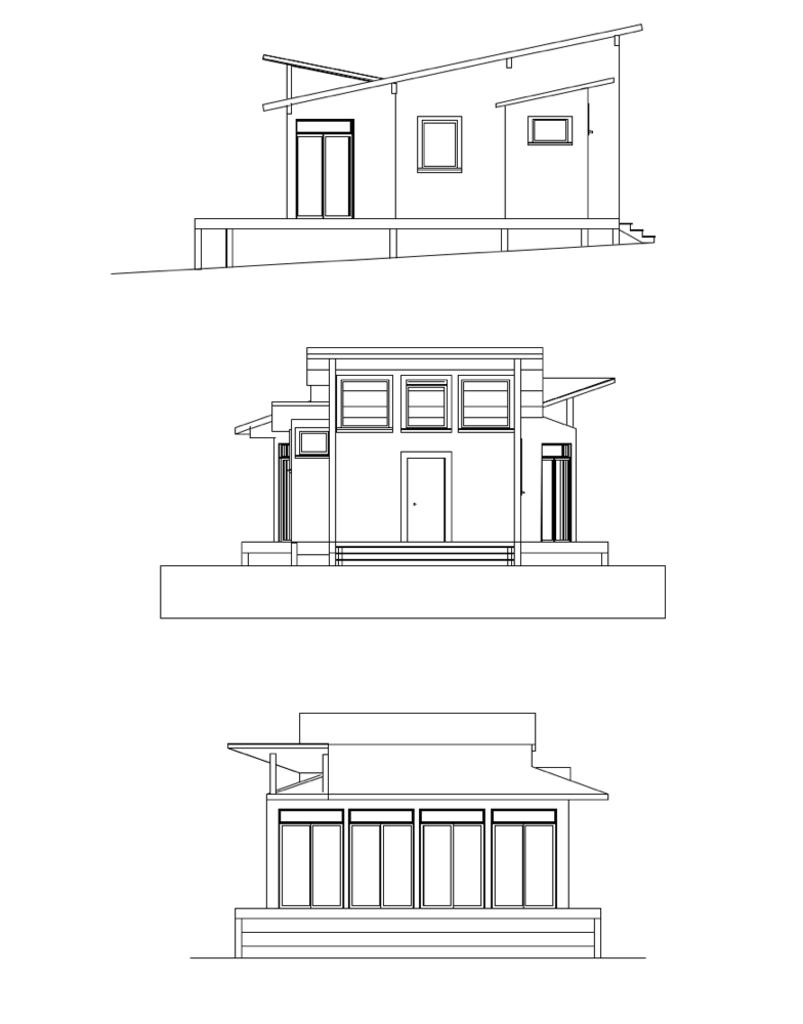What is depicted in the image? There is a drawing of three houses in the image. Can you describe the houses in the drawing? Unfortunately, the facts provided do not give any details about the appearance of the houses. Are there any other elements in the image besides the houses? The facts provided do not mention any other elements in the image. How many thumbs can be seen in the image? There are no thumbs present in the image, as it only contains a drawing of three houses. 